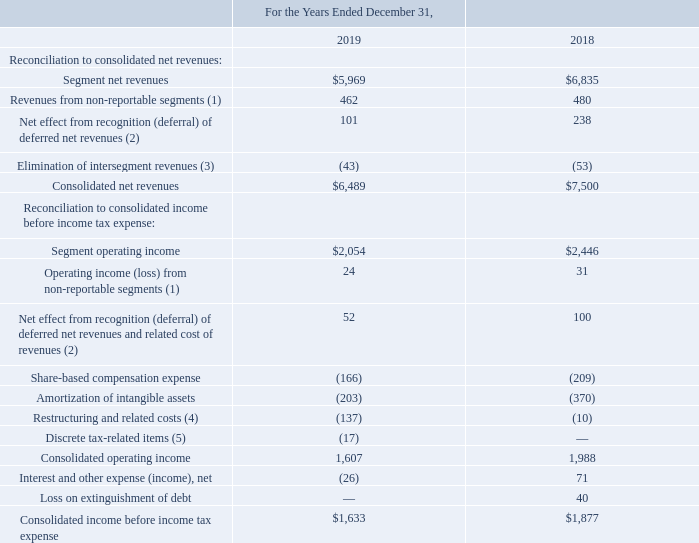Reconciliations of total segment net revenues and total segment operating income to consolidated net revenues and consolidated income before income tax expense are presented in the table below (amounts in millions):
(1) Includes other income and expenses from operating segments managed outside the reportable segments, including our Distribution business. Also includes unallocated corporate income and expenses.
(2) Since certain of our games are hosted online or include significant online functionality that represents a separate performance obligation, we defer the transaction price allocable to the online functionality from the sale of these games and then recognize the attributable revenues over the relevant estimated service periods, which are generally less than a year. The related cost of revenues is deferred and recognized as an expense as the related revenues are recognized. This table reflects the net effect from the deferrals of revenues and recognition of deferred revenues, along with the related cost of revenues, on certain of our online enabled products.
(3) Intersegment revenues reflect licensing and service fees charged between segments.
(4) Reflects restructuring initiatives, which include severance and other restructuring-related costs.
(5) Reflects the impact of other unusual or unique tax‑related items and activities.
What does intersegment revenues reflect? Licensing and service fees charged between segments. What is the segment operating income in 2019?
Answer scale should be: million. $2,054. What is the segment net revenues in 2018?
Answer scale should be: million. $6,835. What is the percentage change in segment net revenues between 2018 and 2019?
Answer scale should be: percent. ($5,969-$6,835)/$6,835
Answer: -12.67. What is the percentage change in segment operating income between 2018 and 2019?
Answer scale should be: percent. ($2,054-$2,446)/$2,446
Answer: -16.03. What is the change in revenues from non-reportable segments between 2018 and 2019?
Answer scale should be: million. (462-480)
Answer: -18. 